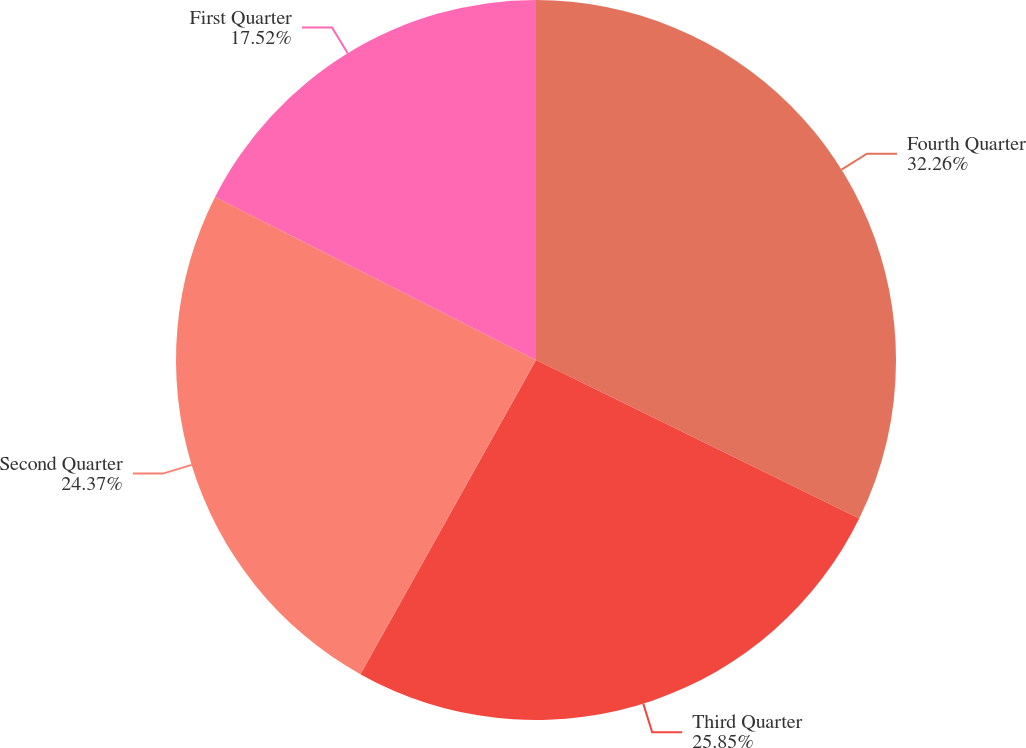Convert chart. <chart><loc_0><loc_0><loc_500><loc_500><pie_chart><fcel>Fourth Quarter<fcel>Third Quarter<fcel>Second Quarter<fcel>First Quarter<nl><fcel>32.26%<fcel>25.85%<fcel>24.37%<fcel>17.52%<nl></chart> 